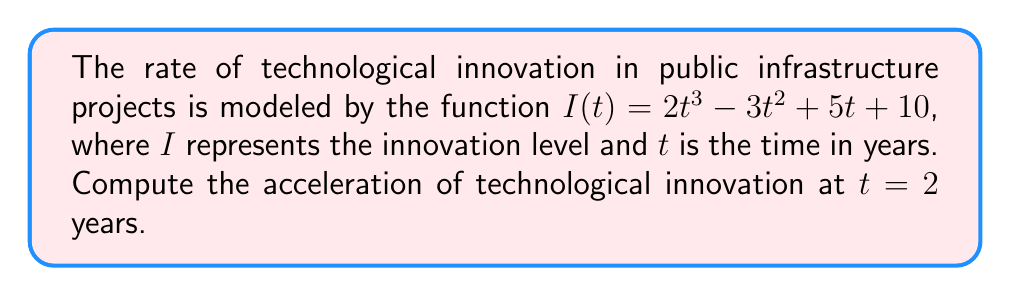Show me your answer to this math problem. To find the acceleration of technological innovation, we need to calculate the second derivative of the given function $I(t)$ and evaluate it at $t = 2$.

Step 1: Calculate the first derivative (velocity of innovation)
$$\frac{dI}{dt} = I'(t) = 6t^2 - 6t + 5$$

Step 2: Calculate the second derivative (acceleration of innovation)
$$\frac{d^2I}{dt^2} = I''(t) = 12t - 6$$

Step 3: Evaluate the second derivative at $t = 2$
$$I''(2) = 12(2) - 6 = 24 - 6 = 18$$

Therefore, the acceleration of technological innovation at $t = 2$ years is 18 units per year squared.
Answer: $18$ units/year² 